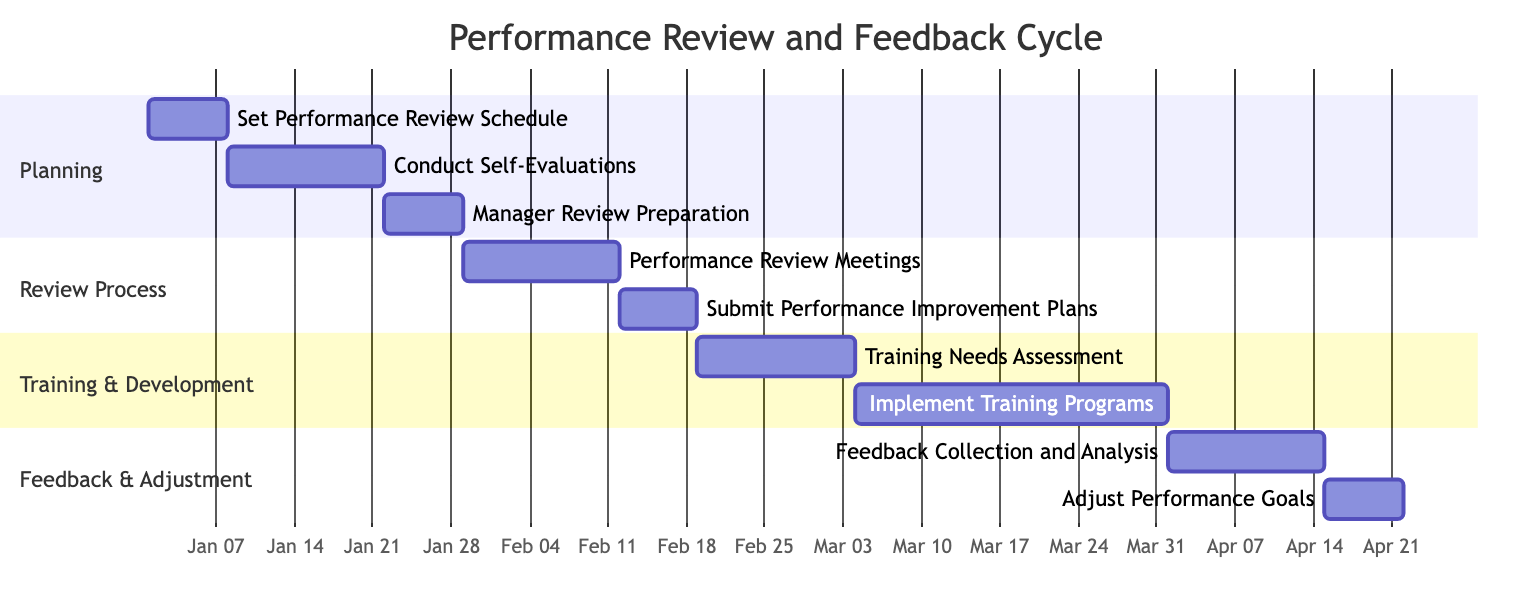What is the duration of the "Set Performance Review Schedule" task? The task "Set Performance Review Schedule" has a duration specified as "1 week." This can be directly observed from the diagram where the task is indicated alongside its duration information.
Answer: 1 week What task follows "Conduct Self-Evaluations"? The task that follows "Conduct Self-Evaluations" is "Manager Review Preparation." By visual inspection of the Gantt chart, one can see the sequence of tasks, with "Manager Review Preparation" positioned immediately after "Conduct Self-Evaluations."
Answer: Manager Review Preparation How long is the "Implement Training Programs" phase? The "Implement Training Programs" is listed with a duration of "4 weeks." This is directly indicated in the Gantt chart, which shows the duration for this specific task clearly.
Answer: 4 weeks What's the total number of activities in the "Training & Development" section? There are two activities in the "Training & Development" section: "Training Needs Assessment" and "Implement Training Programs." A visual count of the listed tasks under this section confirms the total number of activities.
Answer: 2 Which task comes before "Adjust Performance Goals"? The task that comes before "Adjust Performance Goals" is "Feedback Collection and Analysis." This can be identified by tracing the sequence in the Gantt chart, where "Feedback Collection and Analysis" precedes "Adjust Performance Goals."
Answer: Feedback Collection and Analysis What is the start date of the "Performance Review Meetings"? The "Performance Review Meetings" have a start date of "2024-01-29." This date is explicitly provided next to the task in the Gantt chart, which allows for easy identification of scheduling information.
Answer: 2024-01-29 How many weeks are allocated for collecting feedback and analysis? Two weeks are allocated for collecting feedback and analysis, as stated next to the task "Feedback Collection and Analysis" in the diagram. A quick look at the duration for this task confirms this information.
Answer: 2 weeks Which task has the longest duration in the schedule? The task with the longest duration in the schedule is "Implement Training Programs," which is specified as lasting "4 weeks." This can be confirmed by comparing all task durations depicted in the Gantt chart.
Answer: Implement Training Programs 